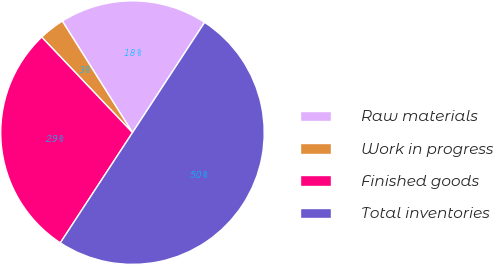Convert chart to OTSL. <chart><loc_0><loc_0><loc_500><loc_500><pie_chart><fcel>Raw materials<fcel>Work in progress<fcel>Finished goods<fcel>Total inventories<nl><fcel>18.16%<fcel>3.16%<fcel>28.68%<fcel>50.0%<nl></chart> 